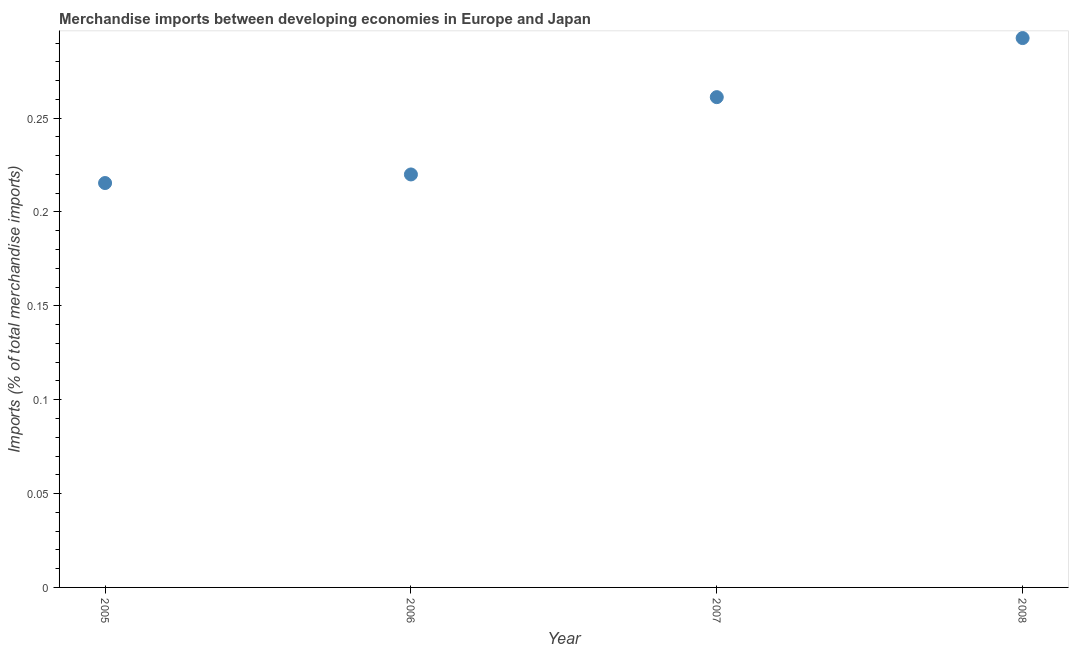What is the merchandise imports in 2005?
Your answer should be compact. 0.22. Across all years, what is the maximum merchandise imports?
Give a very brief answer. 0.29. Across all years, what is the minimum merchandise imports?
Your answer should be very brief. 0.22. What is the sum of the merchandise imports?
Your answer should be very brief. 0.99. What is the difference between the merchandise imports in 2007 and 2008?
Provide a short and direct response. -0.03. What is the average merchandise imports per year?
Provide a succinct answer. 0.25. What is the median merchandise imports?
Offer a terse response. 0.24. Do a majority of the years between 2006 and 2008 (inclusive) have merchandise imports greater than 0.25 %?
Provide a succinct answer. Yes. What is the ratio of the merchandise imports in 2005 to that in 2006?
Make the answer very short. 0.98. Is the merchandise imports in 2006 less than that in 2007?
Make the answer very short. Yes. Is the difference between the merchandise imports in 2005 and 2007 greater than the difference between any two years?
Provide a succinct answer. No. What is the difference between the highest and the second highest merchandise imports?
Your answer should be very brief. 0.03. What is the difference between the highest and the lowest merchandise imports?
Your answer should be compact. 0.08. What is the difference between two consecutive major ticks on the Y-axis?
Provide a succinct answer. 0.05. Are the values on the major ticks of Y-axis written in scientific E-notation?
Your answer should be very brief. No. Does the graph contain any zero values?
Provide a short and direct response. No. What is the title of the graph?
Ensure brevity in your answer.  Merchandise imports between developing economies in Europe and Japan. What is the label or title of the X-axis?
Make the answer very short. Year. What is the label or title of the Y-axis?
Ensure brevity in your answer.  Imports (% of total merchandise imports). What is the Imports (% of total merchandise imports) in 2005?
Ensure brevity in your answer.  0.22. What is the Imports (% of total merchandise imports) in 2006?
Your answer should be compact. 0.22. What is the Imports (% of total merchandise imports) in 2007?
Offer a terse response. 0.26. What is the Imports (% of total merchandise imports) in 2008?
Offer a terse response. 0.29. What is the difference between the Imports (% of total merchandise imports) in 2005 and 2006?
Provide a short and direct response. -0. What is the difference between the Imports (% of total merchandise imports) in 2005 and 2007?
Offer a very short reply. -0.05. What is the difference between the Imports (% of total merchandise imports) in 2005 and 2008?
Offer a very short reply. -0.08. What is the difference between the Imports (% of total merchandise imports) in 2006 and 2007?
Your answer should be very brief. -0.04. What is the difference between the Imports (% of total merchandise imports) in 2006 and 2008?
Provide a succinct answer. -0.07. What is the difference between the Imports (% of total merchandise imports) in 2007 and 2008?
Your response must be concise. -0.03. What is the ratio of the Imports (% of total merchandise imports) in 2005 to that in 2006?
Your response must be concise. 0.98. What is the ratio of the Imports (% of total merchandise imports) in 2005 to that in 2007?
Keep it short and to the point. 0.82. What is the ratio of the Imports (% of total merchandise imports) in 2005 to that in 2008?
Your response must be concise. 0.74. What is the ratio of the Imports (% of total merchandise imports) in 2006 to that in 2007?
Offer a terse response. 0.84. What is the ratio of the Imports (% of total merchandise imports) in 2006 to that in 2008?
Offer a very short reply. 0.75. What is the ratio of the Imports (% of total merchandise imports) in 2007 to that in 2008?
Offer a very short reply. 0.89. 